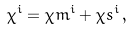<formula> <loc_0><loc_0><loc_500><loc_500>\chi ^ { i } = \chi m ^ { i } + \chi s ^ { i } \, ,</formula> 